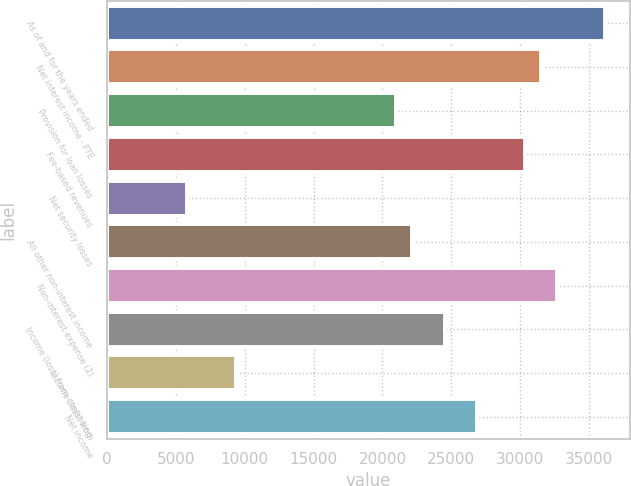Convert chart to OTSL. <chart><loc_0><loc_0><loc_500><loc_500><bar_chart><fcel>As of and for the years ended<fcel>Net interest income - FTE<fcel>Provision for loan losses<fcel>Fee-based revenues<fcel>Net security losses<fcel>All other non-interest income<fcel>Non-interest expense (2)<fcel>Income (loss) from continuing<fcel>Income (loss) from<fcel>Net income<nl><fcel>36182.8<fcel>31514.1<fcel>21009.5<fcel>30346.9<fcel>5836.12<fcel>22176.6<fcel>32681.3<fcel>24511<fcel>9337.66<fcel>26845.4<nl></chart> 